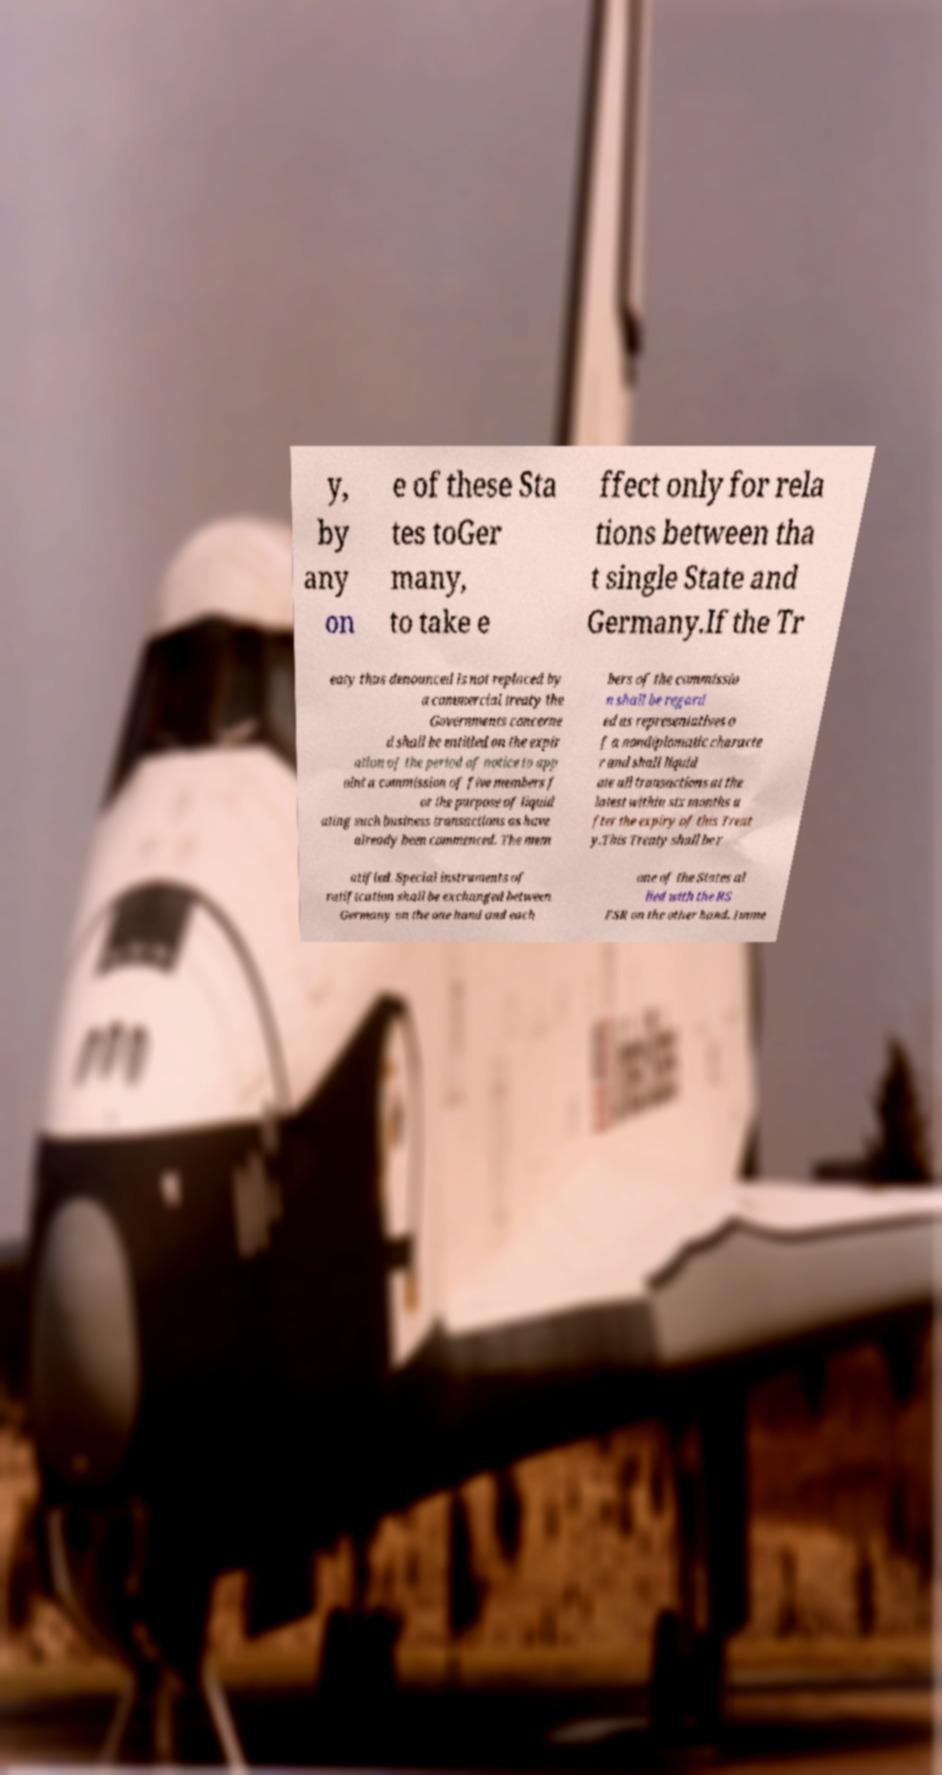I need the written content from this picture converted into text. Can you do that? y, by any on e of these Sta tes toGer many, to take e ffect only for rela tions between tha t single State and Germany.If the Tr eaty thus denounced is not replaced by a commercial treaty the Governments concerne d shall be entitled on the expir ation of the period of notice to app oint a commission of five members f or the purpose of liquid ating such business transactions as have already been commenced. The mem bers of the commissio n shall be regard ed as representatives o f a nondiplomatic characte r and shall liquid ate all transactions at the latest within six months a fter the expiry of this Treat y.This Treaty shall be r atified. Special instruments of ratification shall be exchanged between Germany on the one hand and each one of the States al lied with the RS FSR on the other hand. Imme 